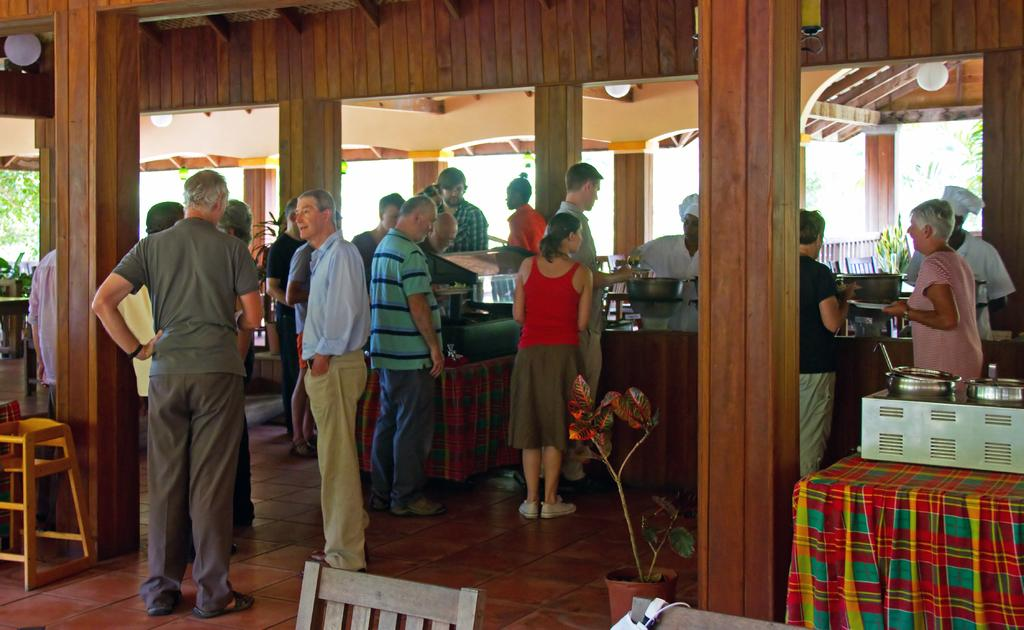What are the people in the image doing? There is a group of people on the floor in the image. What type of plant can be seen in the image? There is a houseplant in the image. What type of containers are present in the image? There are bowls in the image. What type of furniture is in the image? There is a stool in the image. What architectural features are present in the image? There are pillars in the image. What can be seen in the background of the image? There are trees and plants in the background of the image. What type of houses can be seen in the image? There are no houses present in the image. What type of shop is visible in the image? There is no shop present in the image. 